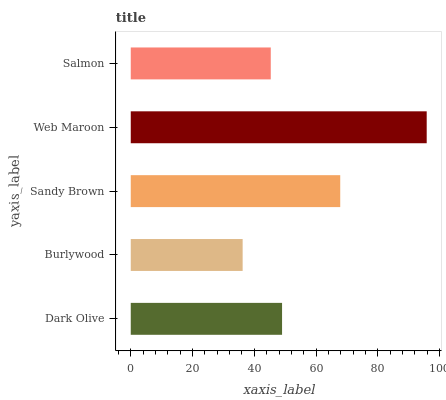Is Burlywood the minimum?
Answer yes or no. Yes. Is Web Maroon the maximum?
Answer yes or no. Yes. Is Sandy Brown the minimum?
Answer yes or no. No. Is Sandy Brown the maximum?
Answer yes or no. No. Is Sandy Brown greater than Burlywood?
Answer yes or no. Yes. Is Burlywood less than Sandy Brown?
Answer yes or no. Yes. Is Burlywood greater than Sandy Brown?
Answer yes or no. No. Is Sandy Brown less than Burlywood?
Answer yes or no. No. Is Dark Olive the high median?
Answer yes or no. Yes. Is Dark Olive the low median?
Answer yes or no. Yes. Is Burlywood the high median?
Answer yes or no. No. Is Sandy Brown the low median?
Answer yes or no. No. 